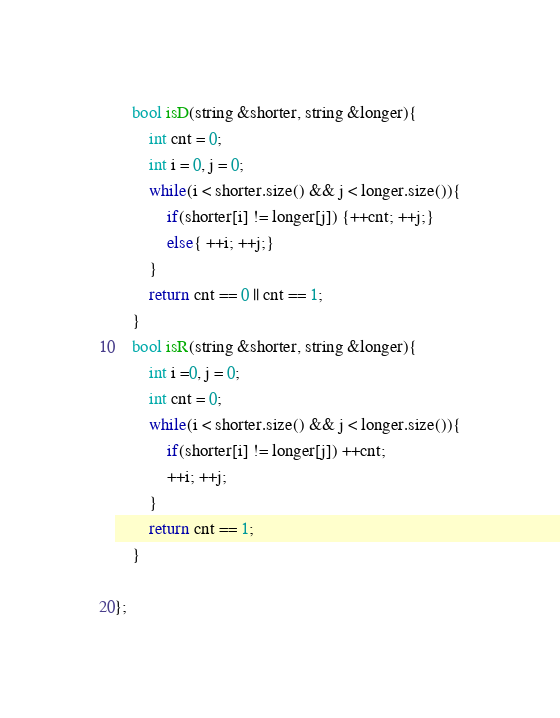Convert code to text. <code><loc_0><loc_0><loc_500><loc_500><_C++_>
    bool isD(string &shorter, string &longer){
        int cnt = 0;
        int i = 0, j = 0;
        while(i < shorter.size() && j < longer.size()){
            if(shorter[i] != longer[j]) {++cnt; ++j;}
            else{ ++i; ++j;}
        }
        return cnt == 0 || cnt == 1;
    }
    bool isR(string &shorter, string &longer){
        int i =0, j = 0;
        int cnt = 0;
        while(i < shorter.size() && j < longer.size()){
            if(shorter[i] != longer[j]) ++cnt;
            ++i; ++j;
        }
        return cnt == 1;
    }

};</code> 